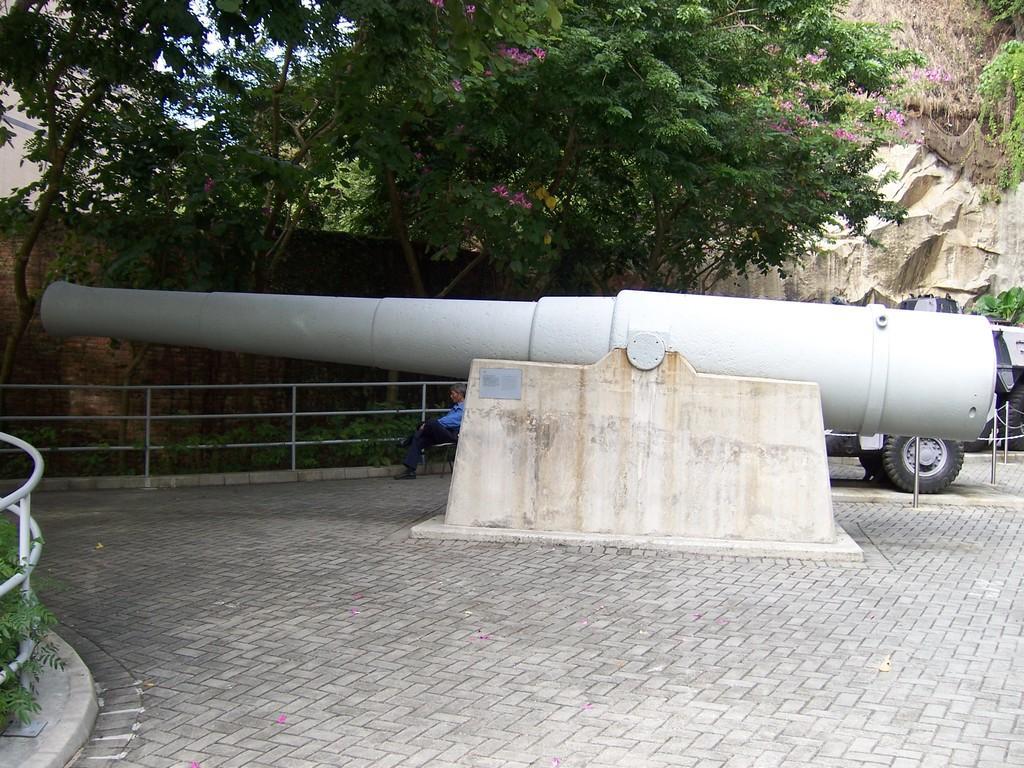Can you describe this image briefly? In the picture I can see trees, fence, a vehicle, a canon and some other objects on the ground. In the background I can see the sky. I can also see a person is sitting on a chair. 